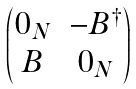<formula> <loc_0><loc_0><loc_500><loc_500>\begin{pmatrix} 0 _ { N } & - B ^ { \dag } \\ B & 0 _ { N } \end{pmatrix}</formula> 